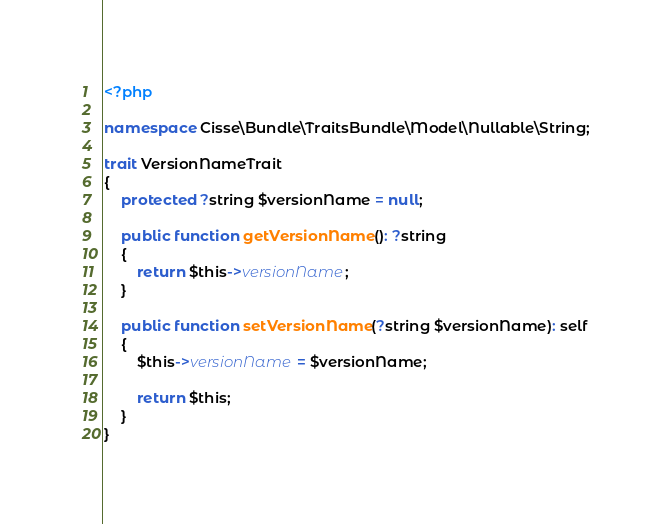<code> <loc_0><loc_0><loc_500><loc_500><_PHP_><?php

namespace Cisse\Bundle\TraitsBundle\Model\Nullable\String;

trait VersionNameTrait
{
    protected ?string $versionName = null;

    public function getVersionName(): ?string
    {
        return $this->versionName;
    }

    public function setVersionName(?string $versionName): self
    {
        $this->versionName = $versionName;

        return $this;
    }
}
</code> 